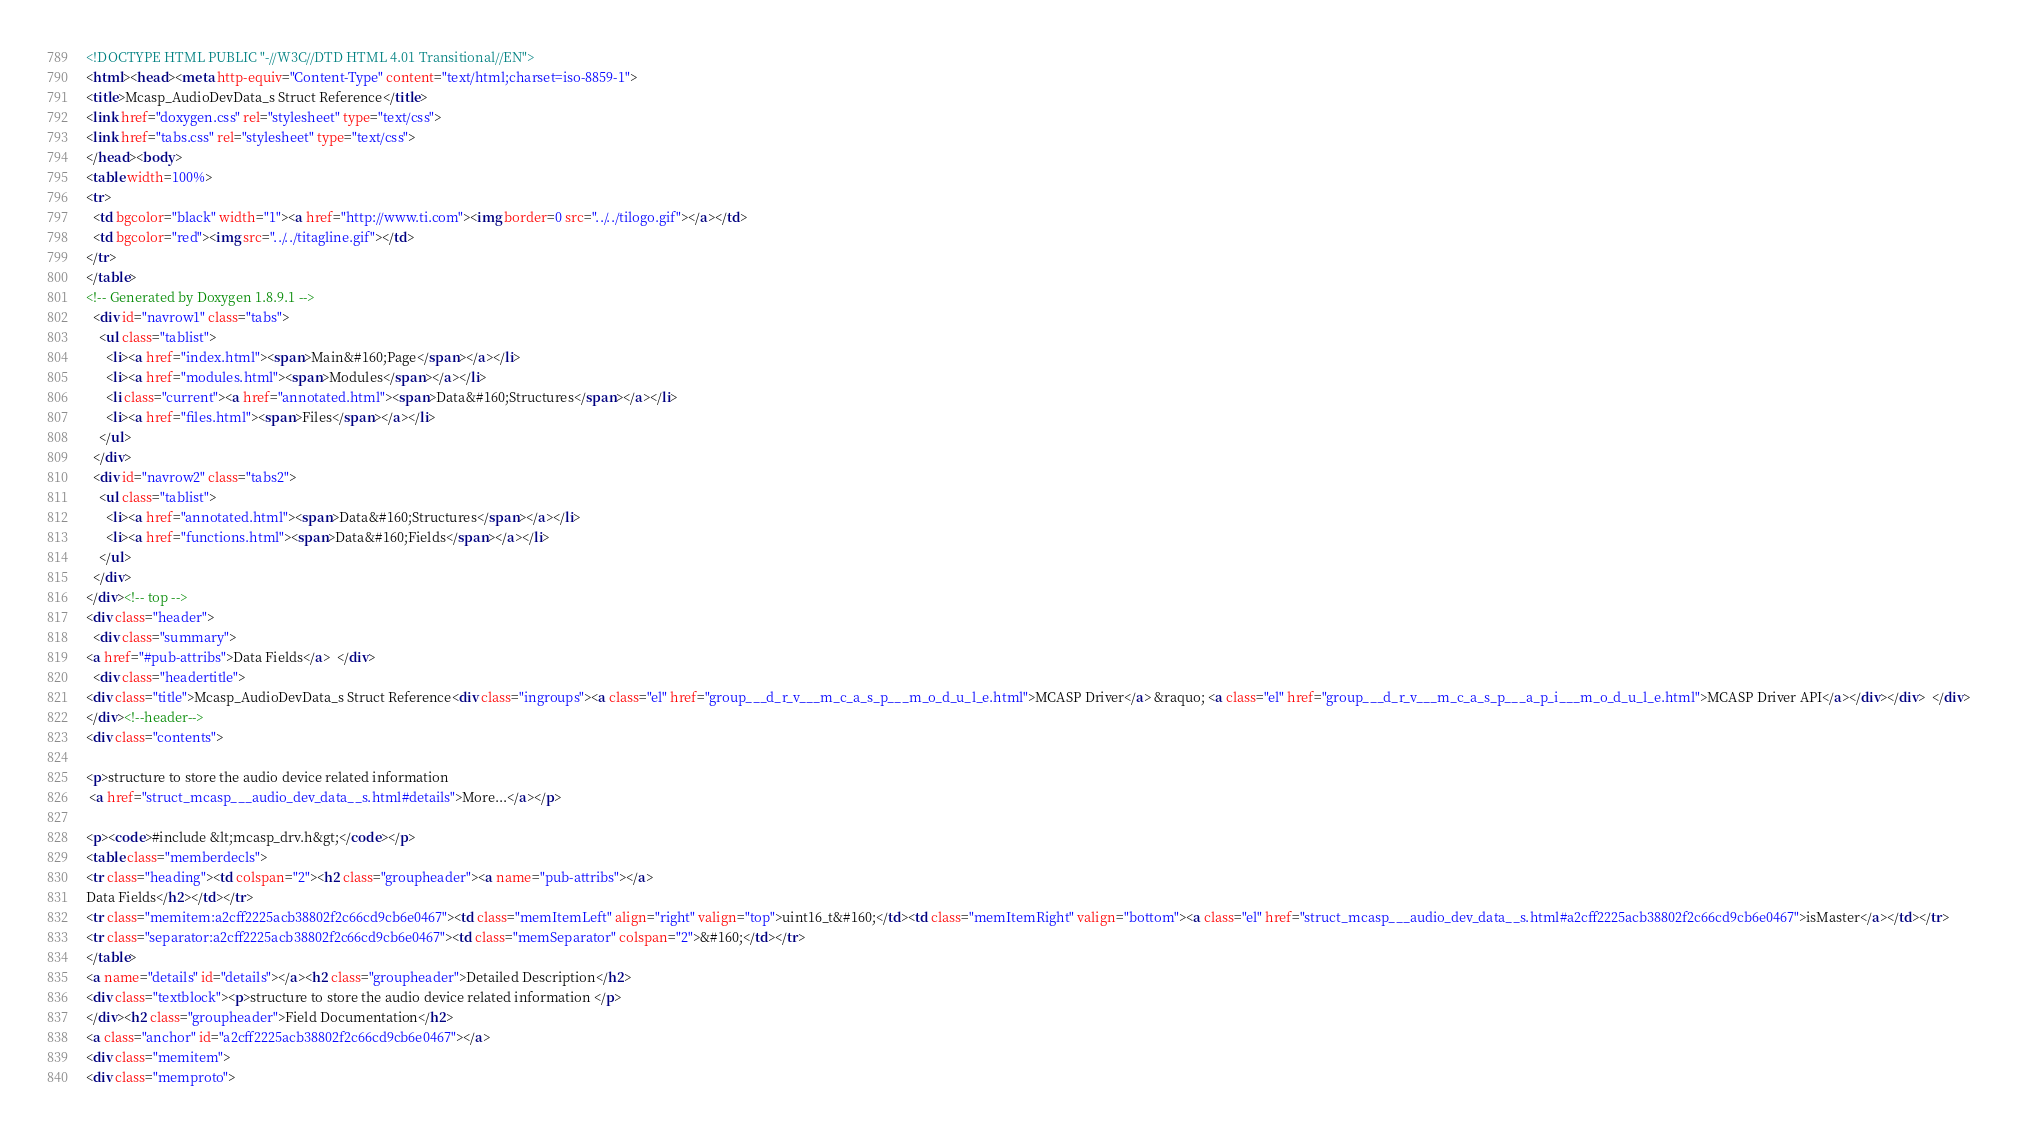<code> <loc_0><loc_0><loc_500><loc_500><_HTML_><!DOCTYPE HTML PUBLIC "-//W3C//DTD HTML 4.01 Transitional//EN">
<html><head><meta http-equiv="Content-Type" content="text/html;charset=iso-8859-1">
<title>Mcasp_AudioDevData_s Struct Reference</title>
<link href="doxygen.css" rel="stylesheet" type="text/css">
<link href="tabs.css" rel="stylesheet" type="text/css">
</head><body>
<table width=100%>
<tr>
  <td bgcolor="black" width="1"><a href="http://www.ti.com"><img border=0 src="../../tilogo.gif"></a></td>
  <td bgcolor="red"><img src="../../titagline.gif"></td>
</tr>
</table>
<!-- Generated by Doxygen 1.8.9.1 -->
  <div id="navrow1" class="tabs">
    <ul class="tablist">
      <li><a href="index.html"><span>Main&#160;Page</span></a></li>
      <li><a href="modules.html"><span>Modules</span></a></li>
      <li class="current"><a href="annotated.html"><span>Data&#160;Structures</span></a></li>
      <li><a href="files.html"><span>Files</span></a></li>
    </ul>
  </div>
  <div id="navrow2" class="tabs2">
    <ul class="tablist">
      <li><a href="annotated.html"><span>Data&#160;Structures</span></a></li>
      <li><a href="functions.html"><span>Data&#160;Fields</span></a></li>
    </ul>
  </div>
</div><!-- top -->
<div class="header">
  <div class="summary">
<a href="#pub-attribs">Data Fields</a>  </div>
  <div class="headertitle">
<div class="title">Mcasp_AudioDevData_s Struct Reference<div class="ingroups"><a class="el" href="group___d_r_v___m_c_a_s_p___m_o_d_u_l_e.html">MCASP Driver</a> &raquo; <a class="el" href="group___d_r_v___m_c_a_s_p___a_p_i___m_o_d_u_l_e.html">MCASP Driver API</a></div></div>  </div>
</div><!--header-->
<div class="contents">

<p>structure to store the audio device related information  
 <a href="struct_mcasp___audio_dev_data__s.html#details">More...</a></p>

<p><code>#include &lt;mcasp_drv.h&gt;</code></p>
<table class="memberdecls">
<tr class="heading"><td colspan="2"><h2 class="groupheader"><a name="pub-attribs"></a>
Data Fields</h2></td></tr>
<tr class="memitem:a2cff2225acb38802f2c66cd9cb6e0467"><td class="memItemLeft" align="right" valign="top">uint16_t&#160;</td><td class="memItemRight" valign="bottom"><a class="el" href="struct_mcasp___audio_dev_data__s.html#a2cff2225acb38802f2c66cd9cb6e0467">isMaster</a></td></tr>
<tr class="separator:a2cff2225acb38802f2c66cd9cb6e0467"><td class="memSeparator" colspan="2">&#160;</td></tr>
</table>
<a name="details" id="details"></a><h2 class="groupheader">Detailed Description</h2>
<div class="textblock"><p>structure to store the audio device related information </p>
</div><h2 class="groupheader">Field Documentation</h2>
<a class="anchor" id="a2cff2225acb38802f2c66cd9cb6e0467"></a>
<div class="memitem">
<div class="memproto"></code> 